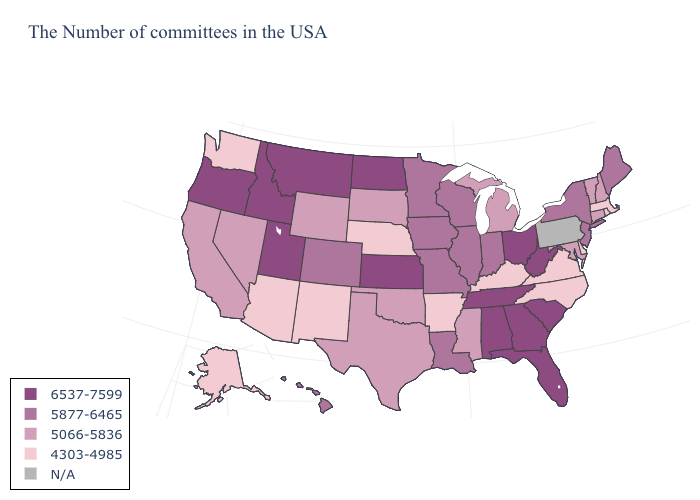Does Michigan have the lowest value in the USA?
Give a very brief answer. No. What is the value of Arizona?
Keep it brief. 4303-4985. Among the states that border Washington , which have the lowest value?
Quick response, please. Idaho, Oregon. Does California have the lowest value in the USA?
Concise answer only. No. Does Oklahoma have the lowest value in the South?
Answer briefly. No. What is the value of Florida?
Answer briefly. 6537-7599. Name the states that have a value in the range 6537-7599?
Concise answer only. South Carolina, West Virginia, Ohio, Florida, Georgia, Alabama, Tennessee, Kansas, North Dakota, Utah, Montana, Idaho, Oregon. Is the legend a continuous bar?
Short answer required. No. What is the highest value in the USA?
Concise answer only. 6537-7599. Does Maryland have the lowest value in the USA?
Be succinct. No. What is the value of Alaska?
Give a very brief answer. 4303-4985. Name the states that have a value in the range N/A?
Short answer required. Pennsylvania. What is the value of Minnesota?
Give a very brief answer. 5877-6465. Which states have the lowest value in the USA?
Short answer required. Massachusetts, Rhode Island, Delaware, Virginia, North Carolina, Kentucky, Arkansas, Nebraska, New Mexico, Arizona, Washington, Alaska. Name the states that have a value in the range 4303-4985?
Quick response, please. Massachusetts, Rhode Island, Delaware, Virginia, North Carolina, Kentucky, Arkansas, Nebraska, New Mexico, Arizona, Washington, Alaska. 